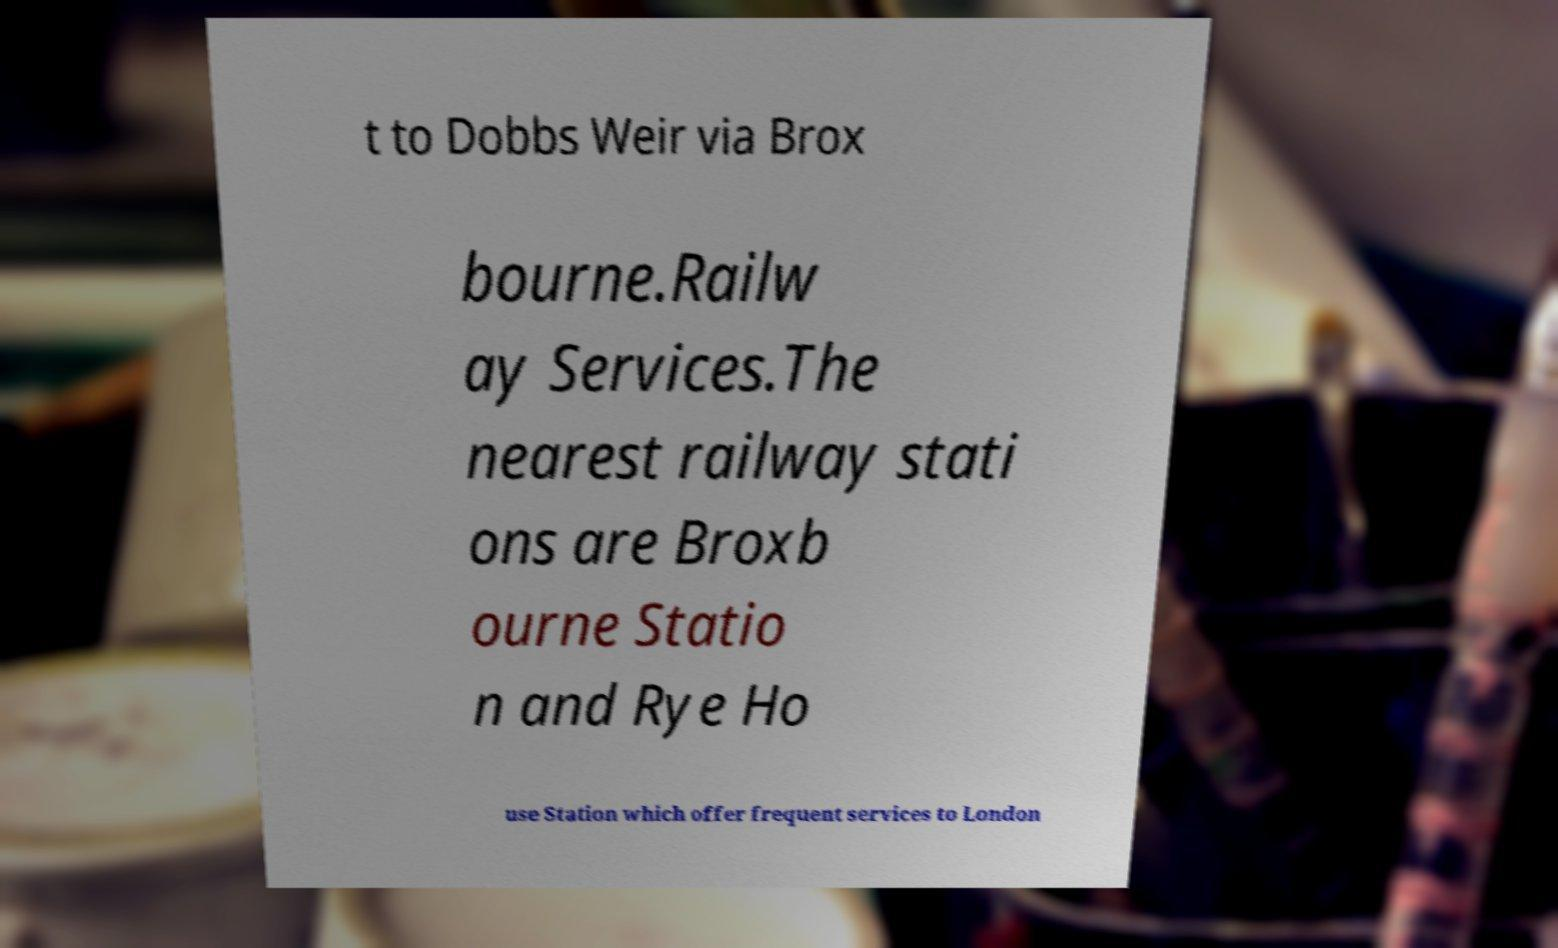I need the written content from this picture converted into text. Can you do that? t to Dobbs Weir via Brox bourne.Railw ay Services.The nearest railway stati ons are Broxb ourne Statio n and Rye Ho use Station which offer frequent services to London 